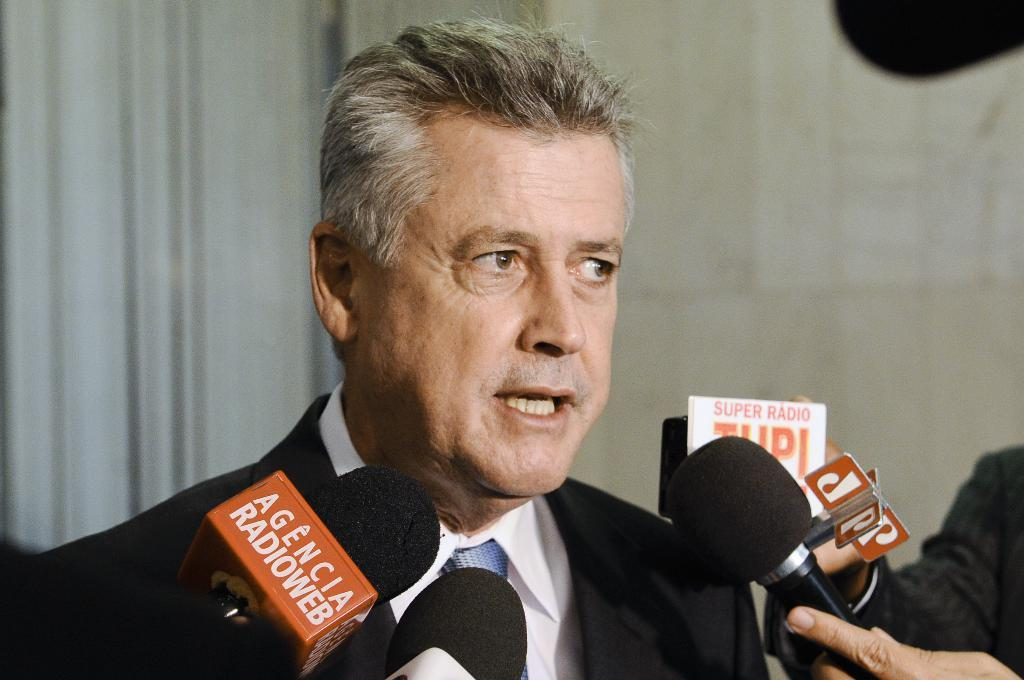Who is present in the image? There is a person in the image. What is the person wearing? The person is wearing a white shirt and a black blazer. Where is the person located in the image? The person is in the middle of the image. What can be seen at the bottom of the image? There are mice at the bottom of the image. What is visible in the background of the image? There is a wall in the background of the image. What type of rail system is visible in the image? There is no rail system present in the image. What power source is being used by the person in the image? The image does not provide information about any power source being used by the person. 